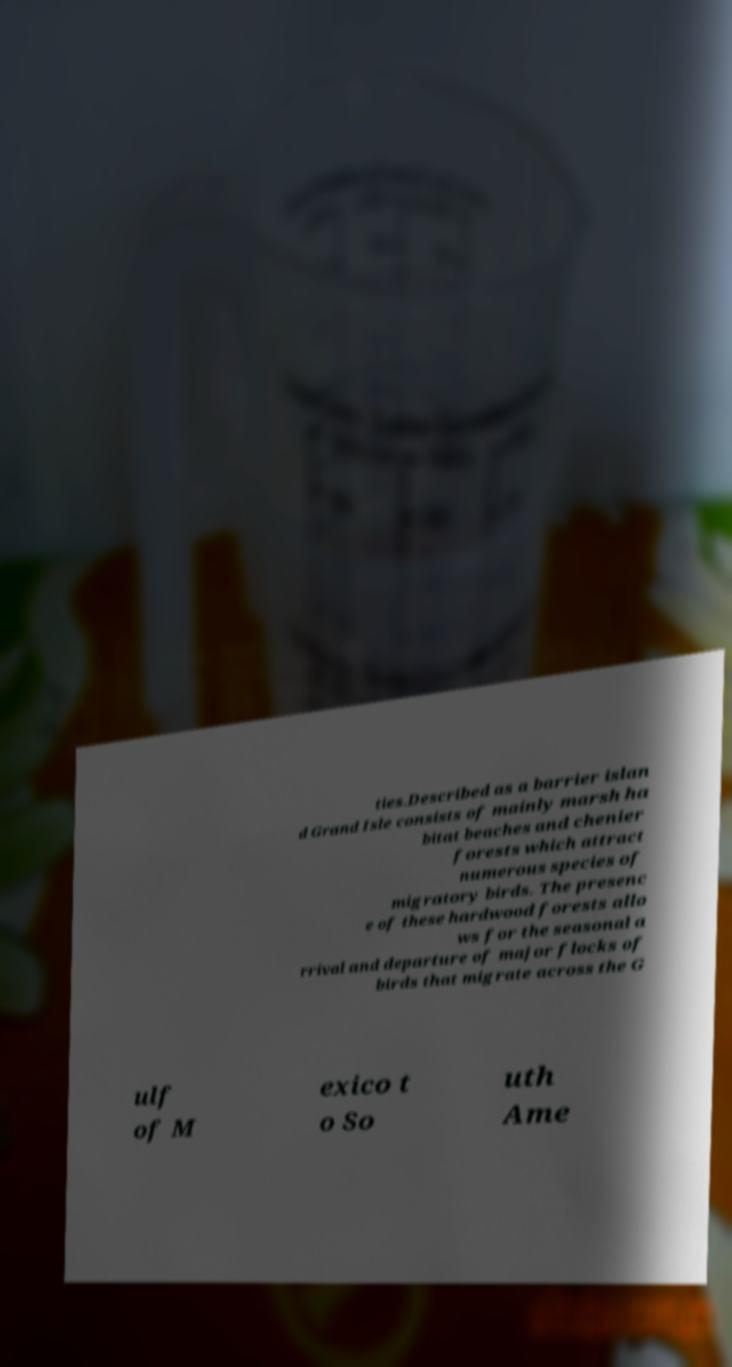Please read and relay the text visible in this image. What does it say? ties.Described as a barrier islan d Grand Isle consists of mainly marsh ha bitat beaches and chenier forests which attract numerous species of migratory birds. The presenc e of these hardwood forests allo ws for the seasonal a rrival and departure of major flocks of birds that migrate across the G ulf of M exico t o So uth Ame 